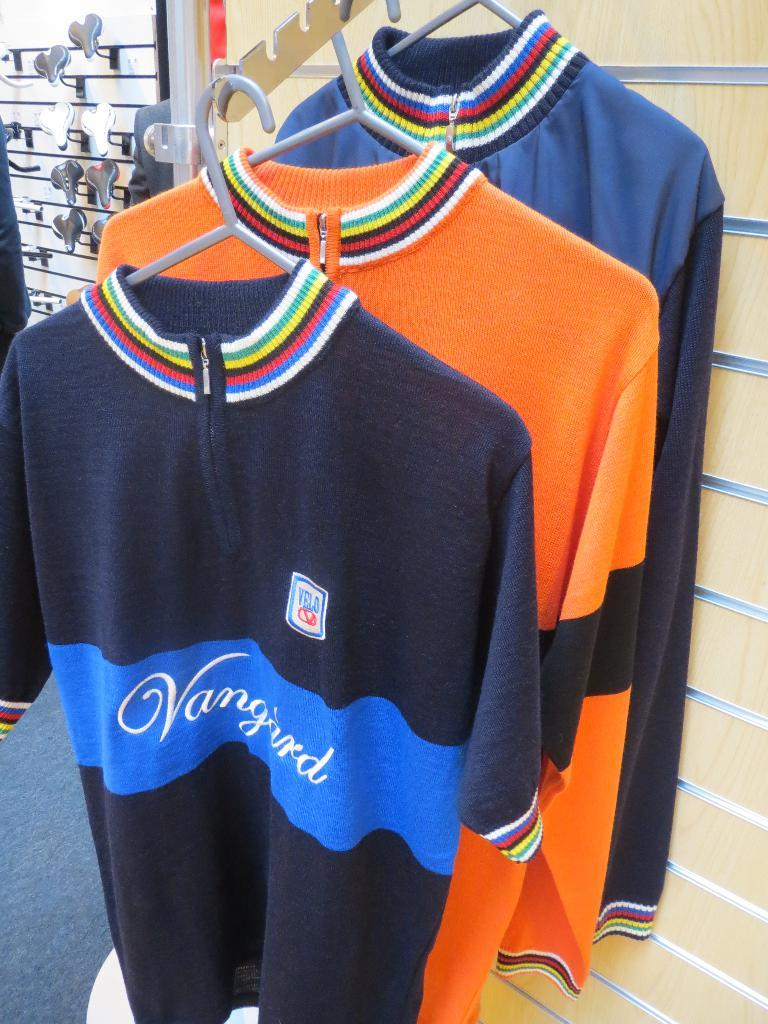<image>
Present a compact description of the photo's key features. A rack of shirts, the front one says Vanguard. 